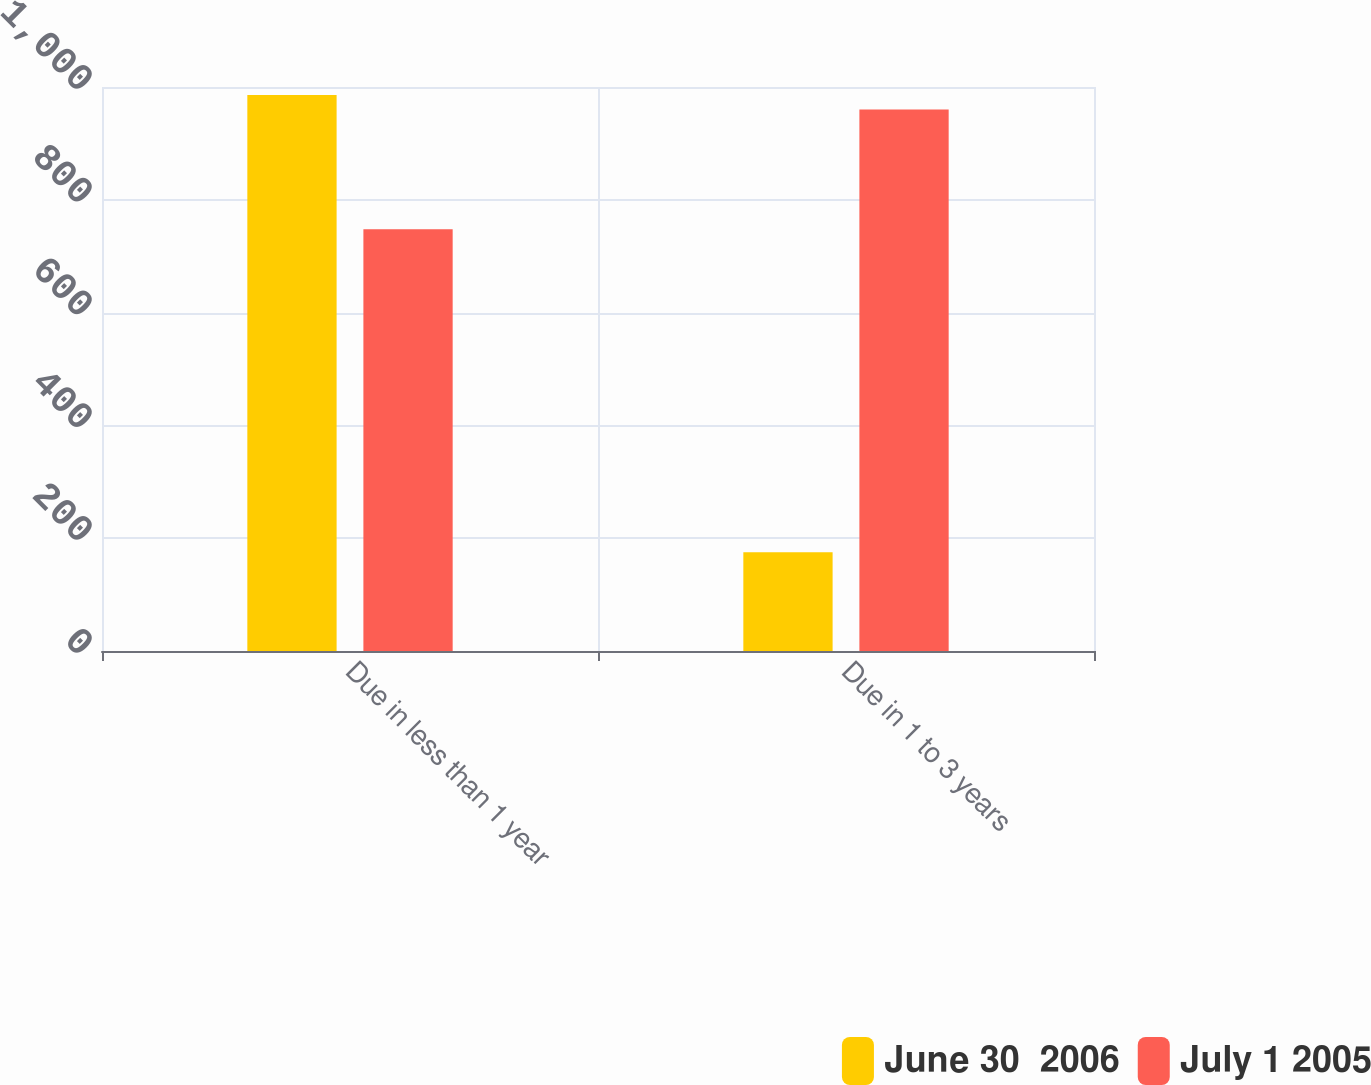Convert chart. <chart><loc_0><loc_0><loc_500><loc_500><stacked_bar_chart><ecel><fcel>Due in less than 1 year<fcel>Due in 1 to 3 years<nl><fcel>June 30  2006<fcel>986<fcel>175<nl><fcel>July 1 2005<fcel>748<fcel>960<nl></chart> 